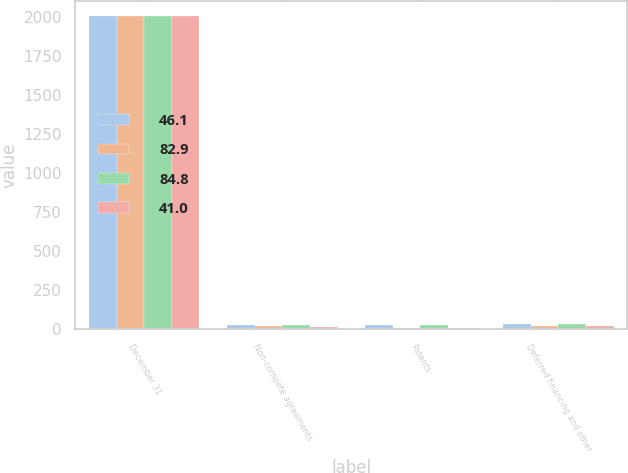Convert chart to OTSL. <chart><loc_0><loc_0><loc_500><loc_500><stacked_bar_chart><ecel><fcel>December 31<fcel>Non-compete agreements<fcel>Patents<fcel>Deferred financing and other<nl><fcel>46.1<fcel>2002<fcel>26.2<fcel>24.7<fcel>32<nl><fcel>82.9<fcel>2002<fcel>17.6<fcel>6.9<fcel>21.6<nl><fcel>84.8<fcel>2001<fcel>27.7<fcel>24.3<fcel>32.8<nl><fcel>41<fcel>2001<fcel>15.6<fcel>6.6<fcel>18.8<nl></chart> 